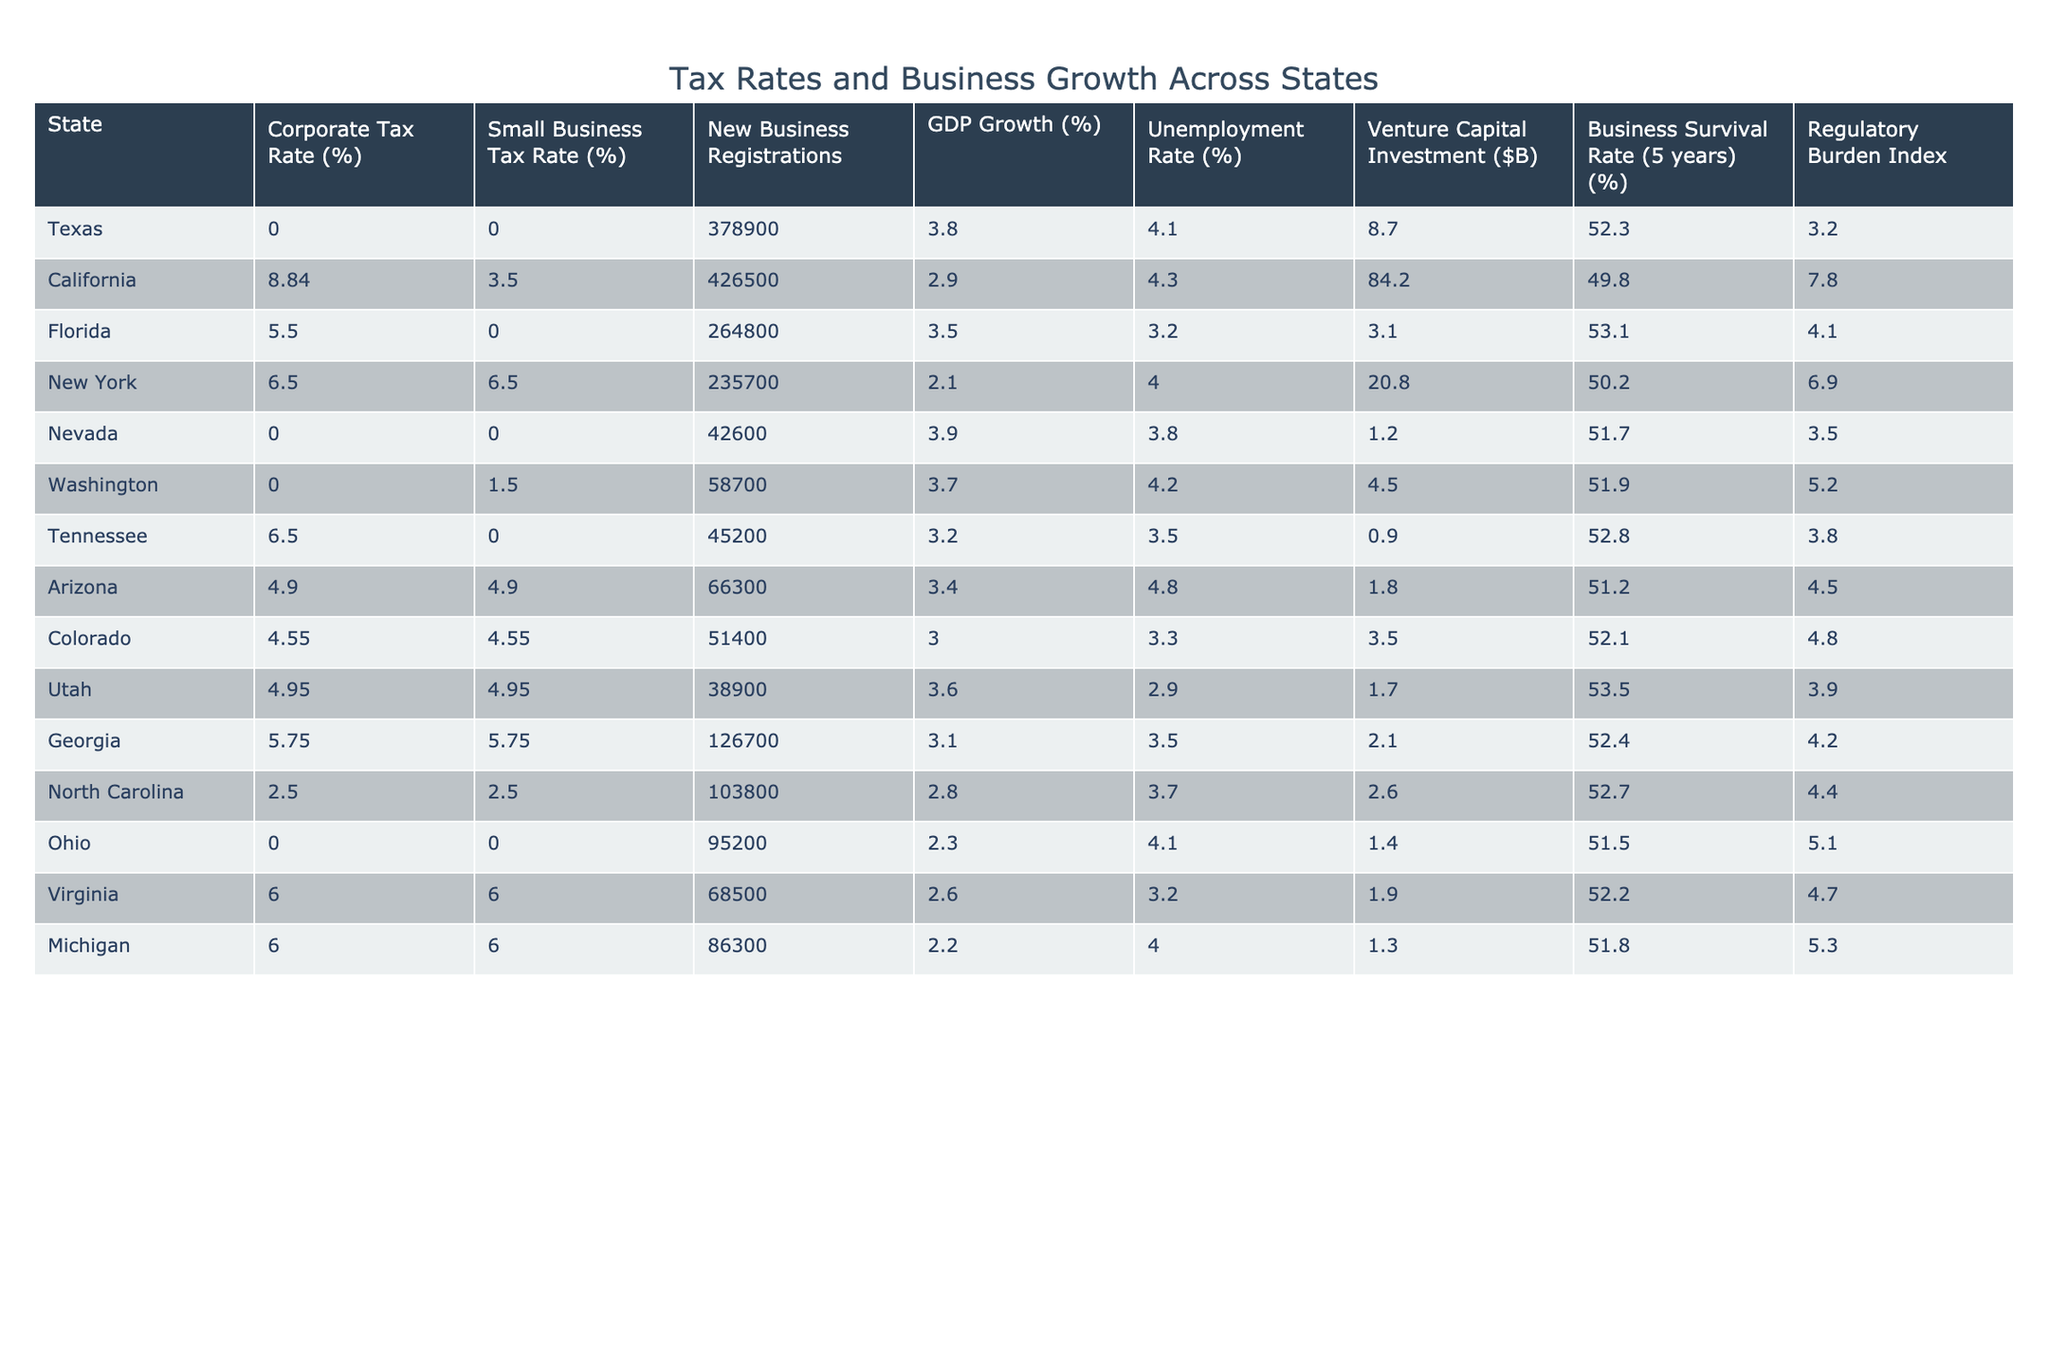What is the corporate tax rate in Texas? Looking at the table, Texas has a corporate tax rate of 0%.
Answer: 0% Which state has the highest rate of venture capital investment? California shows the highest venture capital investment at 84.2 billion dollars.
Answer: 84.2 What is the average GDP growth rate across the states listed? The GDP growth rates for the states are 3.8, 2.9, 3.5, 2.1, 3.9, 3.7, 3.2, 3.4, 3.0, 3.6, 3.1, 2.8, 2.3, 2.6, 2.2 which sum to 51.2. Divided by 15, the average GDP growth rate is 51.2/15 = 3.41%.
Answer: 3.41% Is there a correlation between a state's corporate tax rate and its business survival rate? Texas, Nevada, and Ohio have a corporate tax rate of 0% and their survival rates are 52.3%, 51.7%, and 51.5% respectively, while other states have higher tax rates but lower survival rates, which suggests a possible negative correlation.
Answer: True Which state has the lowest unemployment rate and what is that rate? Florida has the lowest unemployment rate at 3.2%.
Answer: 3.2% How many new business registrations were there in California compared to Texas? California registered 426,500 new businesses while Texas registered 378,900. The difference is 426,500 - 378,900 = 47,600 more registrations in California.
Answer: 47,600 What percentage of businesses survive for 5 years in North Carolina? The business survival rate in North Carolina is 52.7%.
Answer: 52.7% If we summarize the regulatory burden by finding the state with the lowest score, which state is it? Ohio has the lowest regulatory burden index at 5.1.
Answer: Ohio What is the difference in small business tax rates between Florida and New York? Florida has a small business tax rate of 0% while New York has a tax rate of 6.5%. The difference is 6.5% - 0% = 6.5%.
Answer: 6.5% In states with 0% corporate tax rates, what is the average unemployment rate? The states with 0% corporate tax are Texas, Nevada, and Ohio. Their unemployment rates are 4.1%, 3.8%, and 4.1% respectively, which sum to 12% and average out to 12%/3 = 4%.
Answer: 4% 